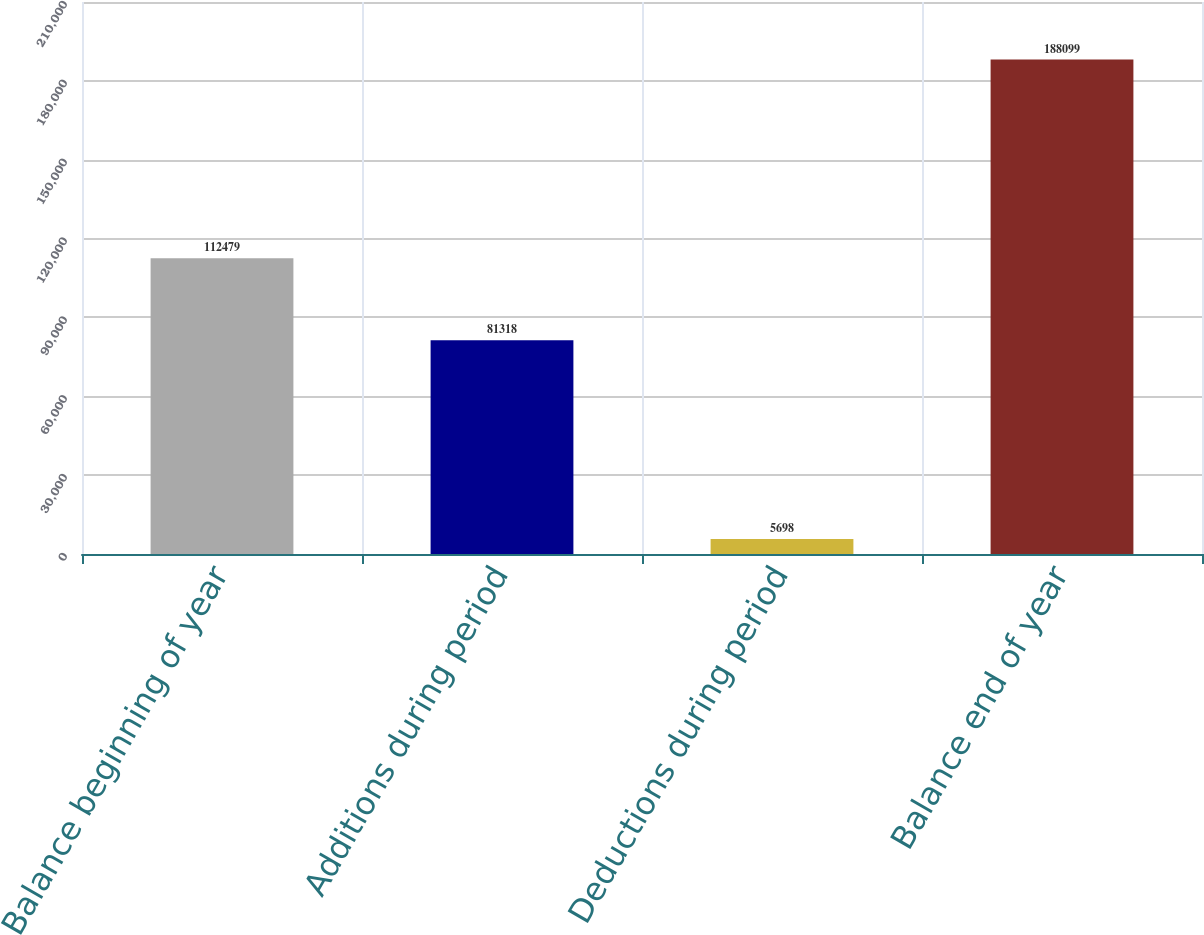Convert chart to OTSL. <chart><loc_0><loc_0><loc_500><loc_500><bar_chart><fcel>Balance beginning of year<fcel>Additions during period<fcel>Deductions during period<fcel>Balance end of year<nl><fcel>112479<fcel>81318<fcel>5698<fcel>188099<nl></chart> 